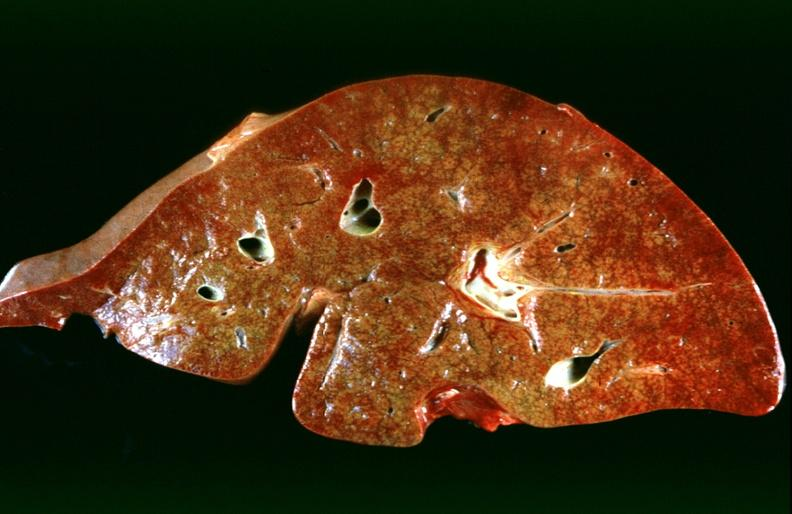does this image show hepatic congestion due to congestive heart failure?
Answer the question using a single word or phrase. Yes 